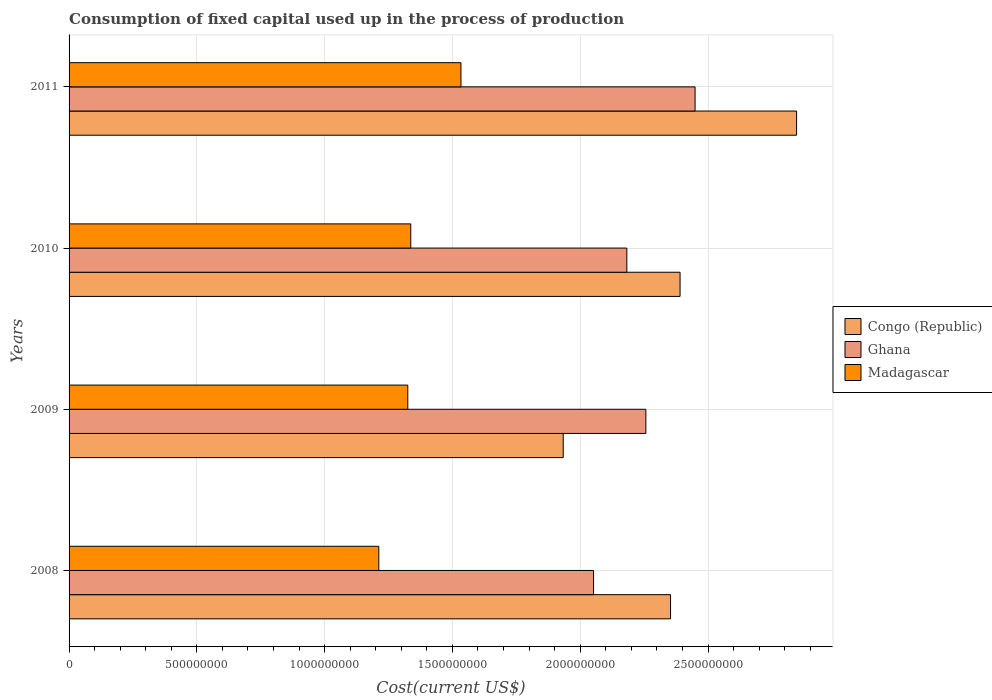How many different coloured bars are there?
Offer a very short reply. 3. Are the number of bars per tick equal to the number of legend labels?
Ensure brevity in your answer.  Yes. Are the number of bars on each tick of the Y-axis equal?
Make the answer very short. Yes. How many bars are there on the 2nd tick from the top?
Your answer should be very brief. 3. How many bars are there on the 2nd tick from the bottom?
Offer a very short reply. 3. What is the amount consumed in the process of production in Ghana in 2010?
Offer a very short reply. 2.18e+09. Across all years, what is the maximum amount consumed in the process of production in Ghana?
Your answer should be compact. 2.45e+09. Across all years, what is the minimum amount consumed in the process of production in Ghana?
Keep it short and to the point. 2.05e+09. In which year was the amount consumed in the process of production in Ghana maximum?
Provide a succinct answer. 2011. What is the total amount consumed in the process of production in Ghana in the graph?
Provide a succinct answer. 8.94e+09. What is the difference between the amount consumed in the process of production in Madagascar in 2008 and that in 2009?
Provide a short and direct response. -1.13e+08. What is the difference between the amount consumed in the process of production in Congo (Republic) in 2010 and the amount consumed in the process of production in Madagascar in 2008?
Your response must be concise. 1.18e+09. What is the average amount consumed in the process of production in Congo (Republic) per year?
Your answer should be very brief. 2.38e+09. In the year 2008, what is the difference between the amount consumed in the process of production in Congo (Republic) and amount consumed in the process of production in Ghana?
Keep it short and to the point. 3.01e+08. In how many years, is the amount consumed in the process of production in Congo (Republic) greater than 1800000000 US$?
Offer a terse response. 4. What is the ratio of the amount consumed in the process of production in Congo (Republic) in 2009 to that in 2010?
Ensure brevity in your answer.  0.81. What is the difference between the highest and the second highest amount consumed in the process of production in Congo (Republic)?
Your answer should be very brief. 4.56e+08. What is the difference between the highest and the lowest amount consumed in the process of production in Ghana?
Ensure brevity in your answer.  3.97e+08. What does the 3rd bar from the top in 2008 represents?
Ensure brevity in your answer.  Congo (Republic). What does the 3rd bar from the bottom in 2010 represents?
Your response must be concise. Madagascar. Is it the case that in every year, the sum of the amount consumed in the process of production in Madagascar and amount consumed in the process of production in Ghana is greater than the amount consumed in the process of production in Congo (Republic)?
Your response must be concise. Yes. Are all the bars in the graph horizontal?
Your response must be concise. Yes. How many years are there in the graph?
Offer a very short reply. 4. What is the difference between two consecutive major ticks on the X-axis?
Make the answer very short. 5.00e+08. Are the values on the major ticks of X-axis written in scientific E-notation?
Keep it short and to the point. No. Does the graph contain any zero values?
Provide a short and direct response. No. Where does the legend appear in the graph?
Your response must be concise. Center right. How many legend labels are there?
Provide a short and direct response. 3. How are the legend labels stacked?
Your answer should be compact. Vertical. What is the title of the graph?
Your answer should be compact. Consumption of fixed capital used up in the process of production. What is the label or title of the X-axis?
Keep it short and to the point. Cost(current US$). What is the label or title of the Y-axis?
Your response must be concise. Years. What is the Cost(current US$) in Congo (Republic) in 2008?
Ensure brevity in your answer.  2.35e+09. What is the Cost(current US$) of Ghana in 2008?
Your answer should be very brief. 2.05e+09. What is the Cost(current US$) in Madagascar in 2008?
Your answer should be very brief. 1.21e+09. What is the Cost(current US$) in Congo (Republic) in 2009?
Your answer should be compact. 1.93e+09. What is the Cost(current US$) in Ghana in 2009?
Make the answer very short. 2.26e+09. What is the Cost(current US$) of Madagascar in 2009?
Your response must be concise. 1.33e+09. What is the Cost(current US$) in Congo (Republic) in 2010?
Your answer should be compact. 2.39e+09. What is the Cost(current US$) in Ghana in 2010?
Provide a short and direct response. 2.18e+09. What is the Cost(current US$) in Madagascar in 2010?
Provide a succinct answer. 1.34e+09. What is the Cost(current US$) of Congo (Republic) in 2011?
Offer a very short reply. 2.85e+09. What is the Cost(current US$) of Ghana in 2011?
Keep it short and to the point. 2.45e+09. What is the Cost(current US$) in Madagascar in 2011?
Make the answer very short. 1.53e+09. Across all years, what is the maximum Cost(current US$) in Congo (Republic)?
Provide a short and direct response. 2.85e+09. Across all years, what is the maximum Cost(current US$) in Ghana?
Your answer should be very brief. 2.45e+09. Across all years, what is the maximum Cost(current US$) in Madagascar?
Ensure brevity in your answer.  1.53e+09. Across all years, what is the minimum Cost(current US$) in Congo (Republic)?
Give a very brief answer. 1.93e+09. Across all years, what is the minimum Cost(current US$) of Ghana?
Your response must be concise. 2.05e+09. Across all years, what is the minimum Cost(current US$) in Madagascar?
Give a very brief answer. 1.21e+09. What is the total Cost(current US$) in Congo (Republic) in the graph?
Provide a short and direct response. 9.52e+09. What is the total Cost(current US$) of Ghana in the graph?
Offer a very short reply. 8.94e+09. What is the total Cost(current US$) in Madagascar in the graph?
Ensure brevity in your answer.  5.41e+09. What is the difference between the Cost(current US$) in Congo (Republic) in 2008 and that in 2009?
Offer a very short reply. 4.20e+08. What is the difference between the Cost(current US$) in Ghana in 2008 and that in 2009?
Make the answer very short. -2.05e+08. What is the difference between the Cost(current US$) of Madagascar in 2008 and that in 2009?
Give a very brief answer. -1.13e+08. What is the difference between the Cost(current US$) of Congo (Republic) in 2008 and that in 2010?
Offer a very short reply. -3.73e+07. What is the difference between the Cost(current US$) in Ghana in 2008 and that in 2010?
Offer a very short reply. -1.30e+08. What is the difference between the Cost(current US$) of Madagascar in 2008 and that in 2010?
Your answer should be very brief. -1.25e+08. What is the difference between the Cost(current US$) in Congo (Republic) in 2008 and that in 2011?
Your answer should be compact. -4.93e+08. What is the difference between the Cost(current US$) of Ghana in 2008 and that in 2011?
Keep it short and to the point. -3.97e+08. What is the difference between the Cost(current US$) of Madagascar in 2008 and that in 2011?
Offer a very short reply. -3.21e+08. What is the difference between the Cost(current US$) in Congo (Republic) in 2009 and that in 2010?
Your response must be concise. -4.57e+08. What is the difference between the Cost(current US$) in Ghana in 2009 and that in 2010?
Your response must be concise. 7.44e+07. What is the difference between the Cost(current US$) in Madagascar in 2009 and that in 2010?
Give a very brief answer. -1.16e+07. What is the difference between the Cost(current US$) in Congo (Republic) in 2009 and that in 2011?
Your answer should be very brief. -9.13e+08. What is the difference between the Cost(current US$) in Ghana in 2009 and that in 2011?
Keep it short and to the point. -1.93e+08. What is the difference between the Cost(current US$) of Madagascar in 2009 and that in 2011?
Your answer should be very brief. -2.08e+08. What is the difference between the Cost(current US$) of Congo (Republic) in 2010 and that in 2011?
Your answer should be very brief. -4.56e+08. What is the difference between the Cost(current US$) of Ghana in 2010 and that in 2011?
Your answer should be very brief. -2.67e+08. What is the difference between the Cost(current US$) of Madagascar in 2010 and that in 2011?
Offer a very short reply. -1.96e+08. What is the difference between the Cost(current US$) in Congo (Republic) in 2008 and the Cost(current US$) in Ghana in 2009?
Give a very brief answer. 9.66e+07. What is the difference between the Cost(current US$) in Congo (Republic) in 2008 and the Cost(current US$) in Madagascar in 2009?
Keep it short and to the point. 1.03e+09. What is the difference between the Cost(current US$) in Ghana in 2008 and the Cost(current US$) in Madagascar in 2009?
Your answer should be compact. 7.27e+08. What is the difference between the Cost(current US$) in Congo (Republic) in 2008 and the Cost(current US$) in Ghana in 2010?
Keep it short and to the point. 1.71e+08. What is the difference between the Cost(current US$) of Congo (Republic) in 2008 and the Cost(current US$) of Madagascar in 2010?
Give a very brief answer. 1.02e+09. What is the difference between the Cost(current US$) of Ghana in 2008 and the Cost(current US$) of Madagascar in 2010?
Your answer should be very brief. 7.15e+08. What is the difference between the Cost(current US$) in Congo (Republic) in 2008 and the Cost(current US$) in Ghana in 2011?
Your answer should be compact. -9.60e+07. What is the difference between the Cost(current US$) of Congo (Republic) in 2008 and the Cost(current US$) of Madagascar in 2011?
Give a very brief answer. 8.20e+08. What is the difference between the Cost(current US$) of Ghana in 2008 and the Cost(current US$) of Madagascar in 2011?
Your answer should be very brief. 5.19e+08. What is the difference between the Cost(current US$) of Congo (Republic) in 2009 and the Cost(current US$) of Ghana in 2010?
Offer a terse response. -2.49e+08. What is the difference between the Cost(current US$) of Congo (Republic) in 2009 and the Cost(current US$) of Madagascar in 2010?
Give a very brief answer. 5.97e+08. What is the difference between the Cost(current US$) of Ghana in 2009 and the Cost(current US$) of Madagascar in 2010?
Keep it short and to the point. 9.20e+08. What is the difference between the Cost(current US$) of Congo (Republic) in 2009 and the Cost(current US$) of Ghana in 2011?
Offer a terse response. -5.16e+08. What is the difference between the Cost(current US$) of Congo (Republic) in 2009 and the Cost(current US$) of Madagascar in 2011?
Keep it short and to the point. 4.00e+08. What is the difference between the Cost(current US$) of Ghana in 2009 and the Cost(current US$) of Madagascar in 2011?
Your answer should be compact. 7.23e+08. What is the difference between the Cost(current US$) of Congo (Republic) in 2010 and the Cost(current US$) of Ghana in 2011?
Offer a terse response. -5.87e+07. What is the difference between the Cost(current US$) of Congo (Republic) in 2010 and the Cost(current US$) of Madagascar in 2011?
Provide a succinct answer. 8.57e+08. What is the difference between the Cost(current US$) of Ghana in 2010 and the Cost(current US$) of Madagascar in 2011?
Give a very brief answer. 6.49e+08. What is the average Cost(current US$) in Congo (Republic) per year?
Your response must be concise. 2.38e+09. What is the average Cost(current US$) of Ghana per year?
Your response must be concise. 2.24e+09. What is the average Cost(current US$) of Madagascar per year?
Your answer should be very brief. 1.35e+09. In the year 2008, what is the difference between the Cost(current US$) in Congo (Republic) and Cost(current US$) in Ghana?
Offer a terse response. 3.01e+08. In the year 2008, what is the difference between the Cost(current US$) in Congo (Republic) and Cost(current US$) in Madagascar?
Provide a succinct answer. 1.14e+09. In the year 2008, what is the difference between the Cost(current US$) of Ghana and Cost(current US$) of Madagascar?
Your answer should be compact. 8.40e+08. In the year 2009, what is the difference between the Cost(current US$) of Congo (Republic) and Cost(current US$) of Ghana?
Make the answer very short. -3.23e+08. In the year 2009, what is the difference between the Cost(current US$) of Congo (Republic) and Cost(current US$) of Madagascar?
Offer a terse response. 6.08e+08. In the year 2009, what is the difference between the Cost(current US$) of Ghana and Cost(current US$) of Madagascar?
Give a very brief answer. 9.31e+08. In the year 2010, what is the difference between the Cost(current US$) of Congo (Republic) and Cost(current US$) of Ghana?
Offer a terse response. 2.08e+08. In the year 2010, what is the difference between the Cost(current US$) in Congo (Republic) and Cost(current US$) in Madagascar?
Your response must be concise. 1.05e+09. In the year 2010, what is the difference between the Cost(current US$) of Ghana and Cost(current US$) of Madagascar?
Your answer should be compact. 8.45e+08. In the year 2011, what is the difference between the Cost(current US$) in Congo (Republic) and Cost(current US$) in Ghana?
Your response must be concise. 3.97e+08. In the year 2011, what is the difference between the Cost(current US$) in Congo (Republic) and Cost(current US$) in Madagascar?
Make the answer very short. 1.31e+09. In the year 2011, what is the difference between the Cost(current US$) of Ghana and Cost(current US$) of Madagascar?
Offer a terse response. 9.16e+08. What is the ratio of the Cost(current US$) of Congo (Republic) in 2008 to that in 2009?
Give a very brief answer. 1.22. What is the ratio of the Cost(current US$) of Ghana in 2008 to that in 2009?
Make the answer very short. 0.91. What is the ratio of the Cost(current US$) of Madagascar in 2008 to that in 2009?
Give a very brief answer. 0.91. What is the ratio of the Cost(current US$) of Congo (Republic) in 2008 to that in 2010?
Keep it short and to the point. 0.98. What is the ratio of the Cost(current US$) in Ghana in 2008 to that in 2010?
Your answer should be compact. 0.94. What is the ratio of the Cost(current US$) in Madagascar in 2008 to that in 2010?
Make the answer very short. 0.91. What is the ratio of the Cost(current US$) in Congo (Republic) in 2008 to that in 2011?
Keep it short and to the point. 0.83. What is the ratio of the Cost(current US$) in Ghana in 2008 to that in 2011?
Your response must be concise. 0.84. What is the ratio of the Cost(current US$) in Madagascar in 2008 to that in 2011?
Provide a short and direct response. 0.79. What is the ratio of the Cost(current US$) of Congo (Republic) in 2009 to that in 2010?
Give a very brief answer. 0.81. What is the ratio of the Cost(current US$) of Ghana in 2009 to that in 2010?
Offer a terse response. 1.03. What is the ratio of the Cost(current US$) in Congo (Republic) in 2009 to that in 2011?
Give a very brief answer. 0.68. What is the ratio of the Cost(current US$) in Ghana in 2009 to that in 2011?
Offer a terse response. 0.92. What is the ratio of the Cost(current US$) in Madagascar in 2009 to that in 2011?
Your answer should be compact. 0.86. What is the ratio of the Cost(current US$) in Congo (Republic) in 2010 to that in 2011?
Ensure brevity in your answer.  0.84. What is the ratio of the Cost(current US$) in Ghana in 2010 to that in 2011?
Keep it short and to the point. 0.89. What is the ratio of the Cost(current US$) of Madagascar in 2010 to that in 2011?
Offer a very short reply. 0.87. What is the difference between the highest and the second highest Cost(current US$) of Congo (Republic)?
Provide a short and direct response. 4.56e+08. What is the difference between the highest and the second highest Cost(current US$) of Ghana?
Make the answer very short. 1.93e+08. What is the difference between the highest and the second highest Cost(current US$) of Madagascar?
Your answer should be compact. 1.96e+08. What is the difference between the highest and the lowest Cost(current US$) of Congo (Republic)?
Provide a succinct answer. 9.13e+08. What is the difference between the highest and the lowest Cost(current US$) of Ghana?
Provide a succinct answer. 3.97e+08. What is the difference between the highest and the lowest Cost(current US$) of Madagascar?
Offer a terse response. 3.21e+08. 